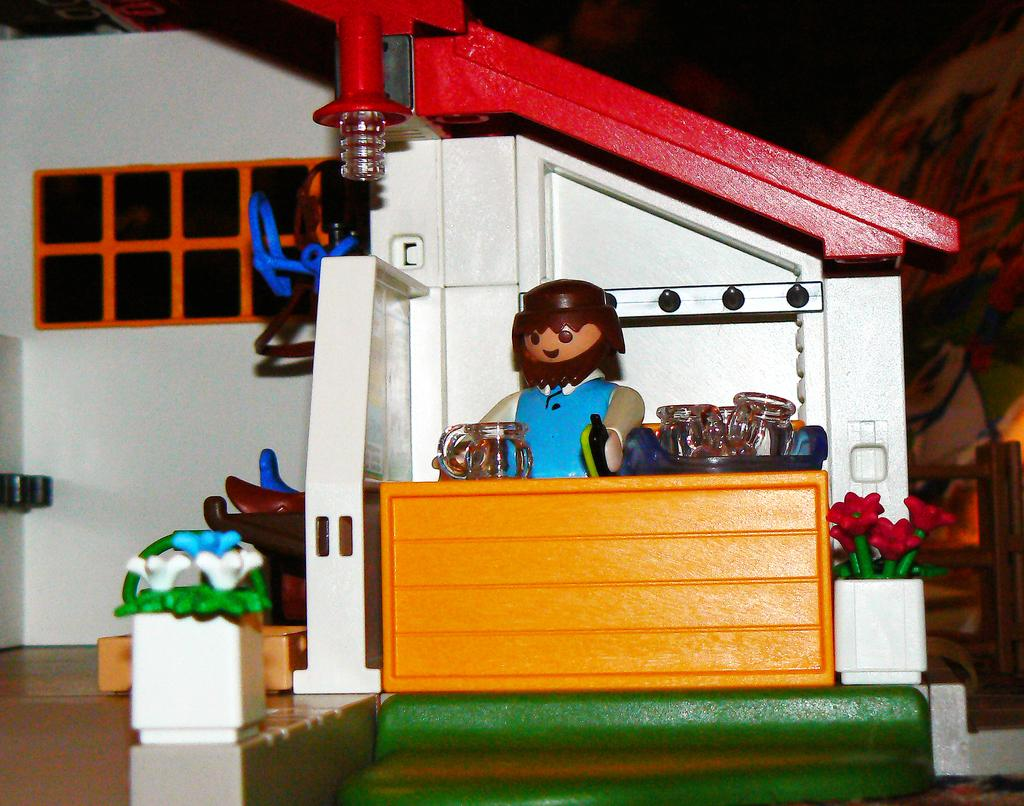What is the main subject of the image? There is a toy house in the center of the image. Can you describe the toy house in more detail? Unfortunately, the provided facts do not give any additional details about the toy house. Is there anything else visible in the image besides the toy house? The provided facts do not mention any other objects or subjects in the image. What type of butter is being used to build the toy house in the image? There is no butter present in the image, and the toy house is not being built; it is already assembled and visible in the center of the image. 